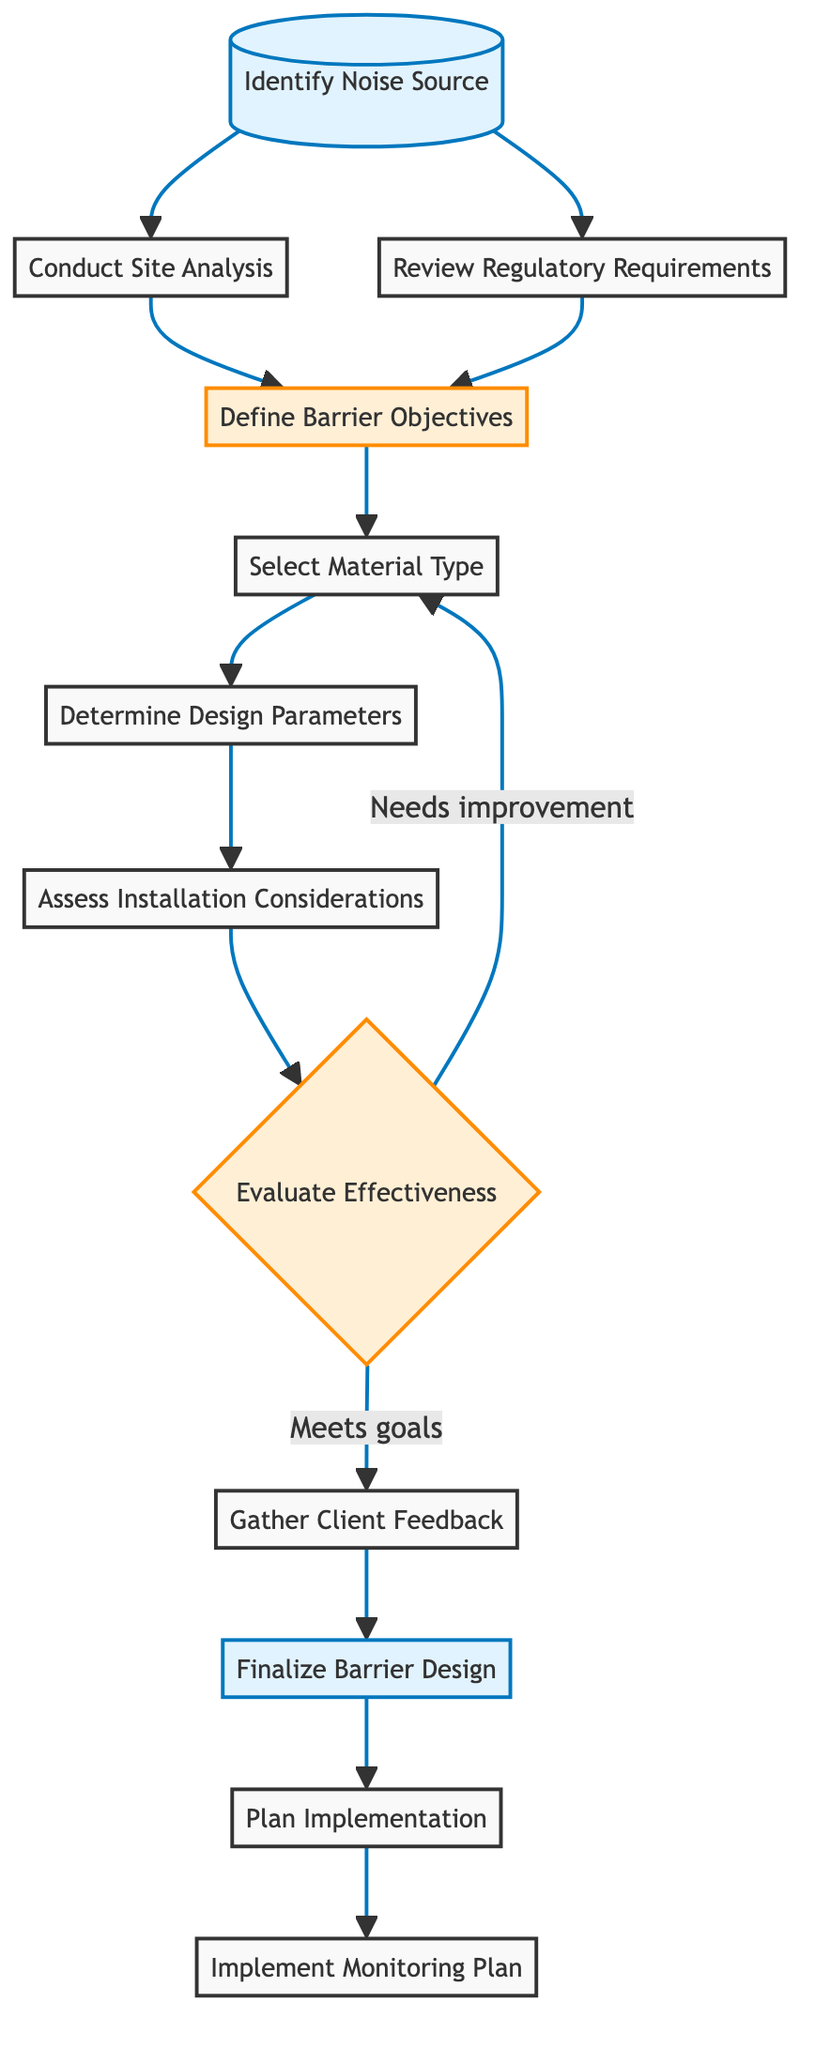What is the first step in the flow chart? The first step indicated in the flow chart is "Identify Noise Source," which is represented as the starting point in the diagram.
Answer: Identify Noise Source How many main elements are in the flow chart? The flow chart contains 12 main elements, including both the decision points and the actions involved in the noise barrier selection process.
Answer: 12 Which node follows "Conduct Site Analysis"? The node that follows "Conduct Site Analysis" is "Define Barrier Objectives," as it is the next logical step in the flow process after conducting the analysis.
Answer: Define Barrier Objectives What happens if "Evaluate Effectiveness" indicates "Needs improvement"? If "Evaluate Effectiveness" indicates "Needs improvement," the process redirects back to "Select Material Type" to reconsider the materials used, showing the iterative nature of the process.
Answer: Select Material Type What are the two options after "Evaluate Effectiveness"? The two options after "Evaluate Effectiveness" are "Meets goals" and "Needs improvement," which guide the subsequent steps based on the effectiveness evaluation.
Answer: Meets goals and Needs improvement What is the final element in the flow chart? The final element in the flow chart is "Implement Monitoring Plan," which signifies the conclusion of the primary process and the initiation of ongoing assessments.
Answer: Implement Monitoring Plan What does "Gather Client Feedback" inform? "Gather Client Feedback" informs adjustments needed based on client satisfaction and effectiveness, highlighting the importance of stakeholder input in the design process.
Answer: Adjustments needed If the design is finalized, which step comes next? Once the design is finalized, the next step is "Plan Implementation," which focuses on preparing for the actual installation and construction of the noise barrier.
Answer: Plan Implementation What type of materials can be selected in the "Select Material Type" node? The materials that can be selected include concrete, wood, earth mounds, and acoustic panels, as per the decision point regarding suitable options for noise barriers.
Answer: Concrete, wood, earth mounds, acoustic panels 